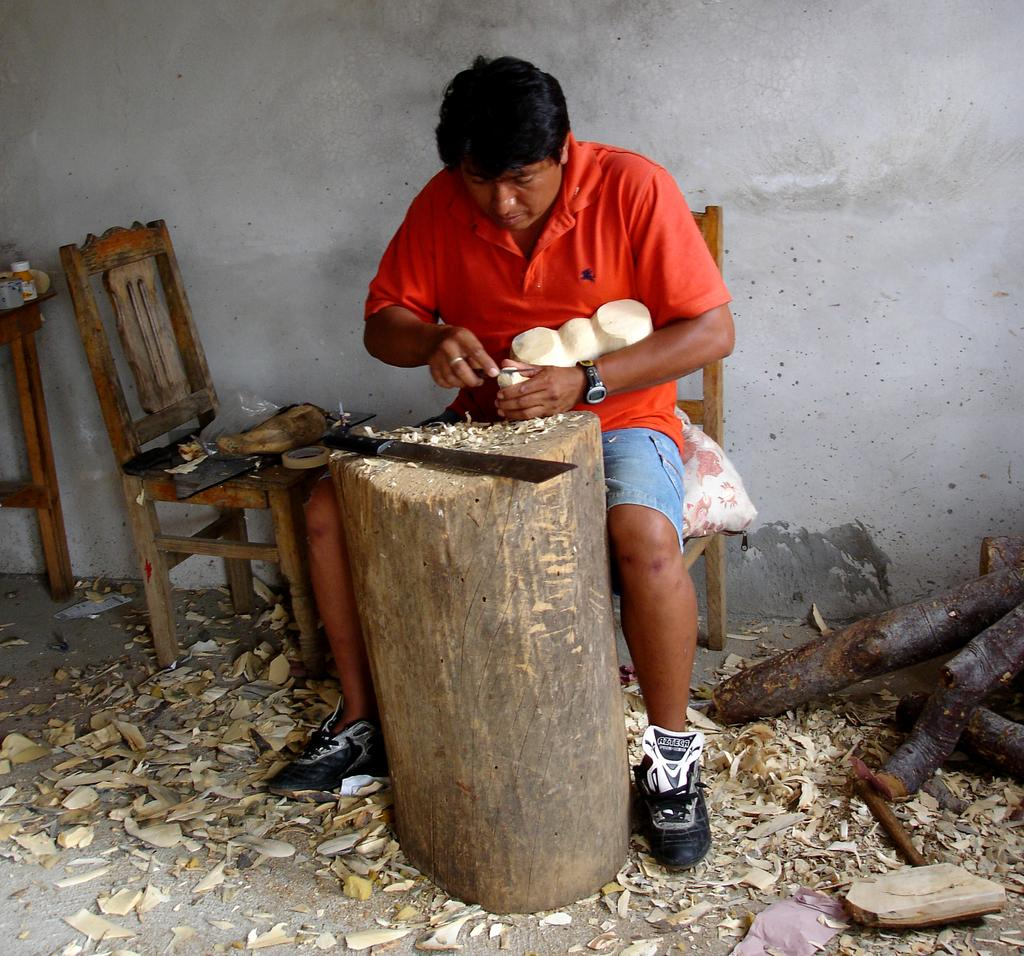What is the person in the image doing? The person is sitting on a chair. What is in front of the person? There is a wooden surface in front of the person. What object is on the wooden surface? There is a sword on the wooden surface. What can be seen on the floor in the image? Tree stems are present on the floor. What news is the person's son delivering in the image? There is no mention of a son or news in the image; it only shows a person sitting on a chair with a wooden surface and a sword in front of them, along with tree stems on the floor. 